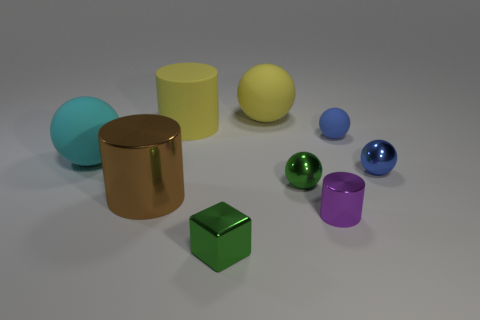Which objects in the image have reflective surfaces? The objects with reflective surfaces in the image are the metal cylinder and two of the spheres, which exhibit shiny and reflective qualities. 